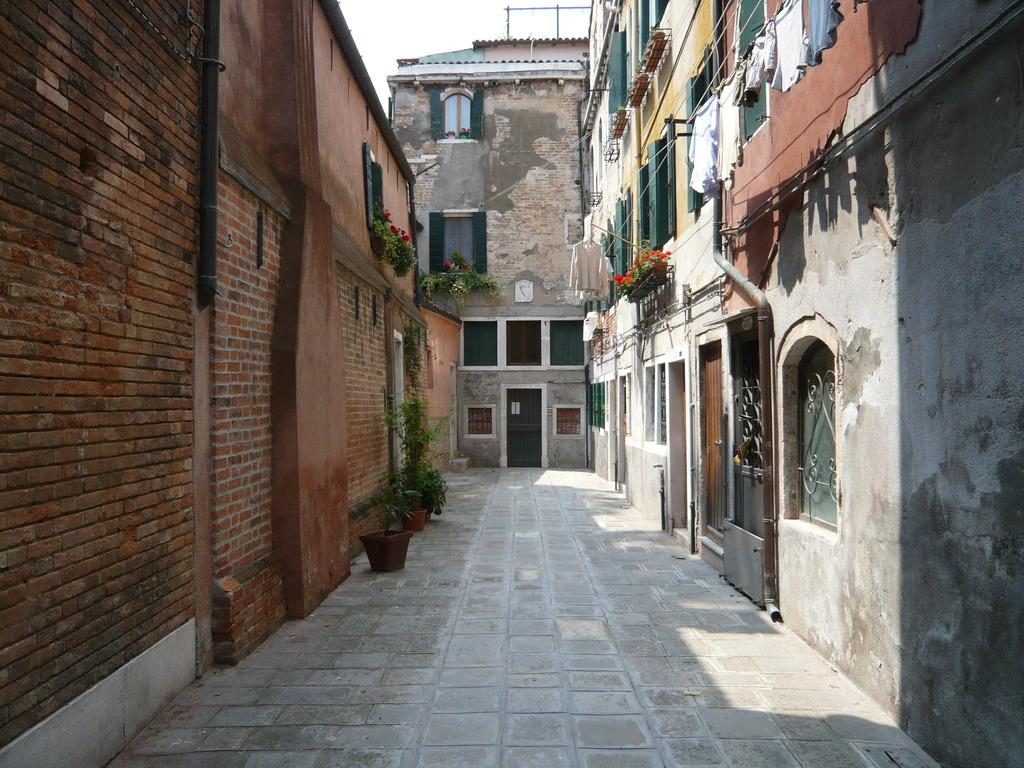What type of structures can be seen in the image? There are buildings in the image. What architectural features are present in the image? There are walls, windows, and doors in the image. What type of vegetation is visible in the image? There are plants in the image. What type of clothing can be seen in the image? There are clothes in the image. What pathway is present in the image? There is a walkway in the image. What is visible at the top of the image? The sky is visible at the top of the image. How much profit can be made from the clothes in the image? There is no information about profit in the image, as it only shows the presence of clothes. What type of card is being used to cook the food in the image? There is no card or cooking activity present in the image; it only shows clothes and other architectural features. 